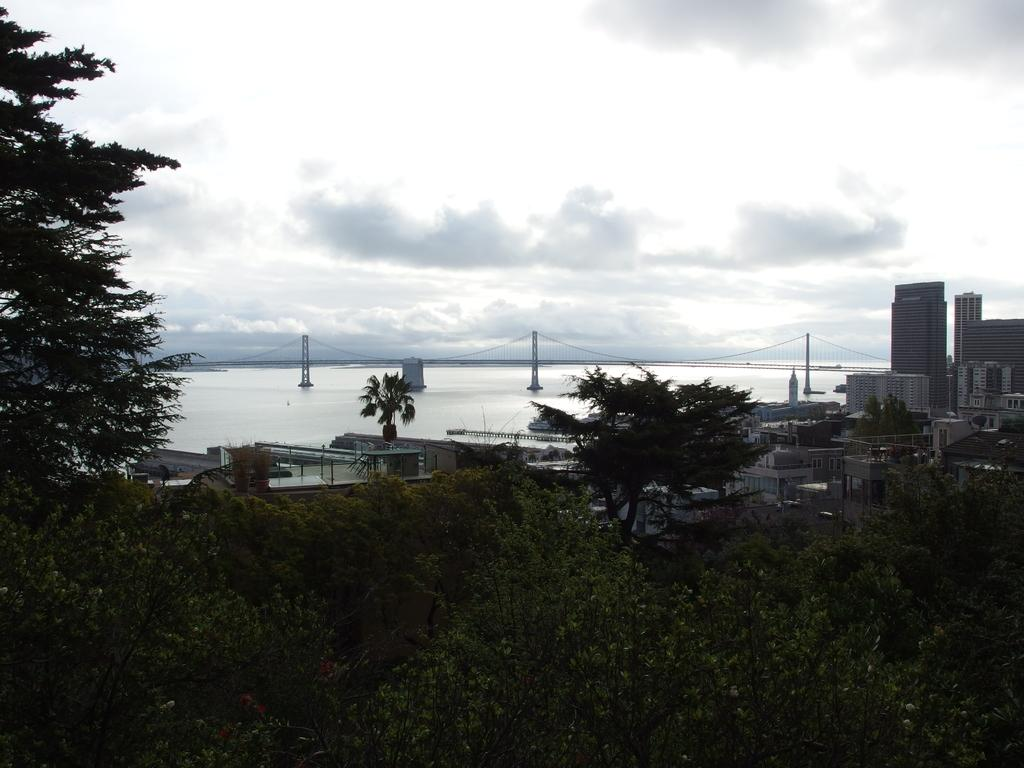What type of natural elements can be seen in the image? There are trees in the image. What type of man-made structures are visible in the image? There are houses and buildings in the image. What architectural feature can be seen in the background of the image? There is a bridge in the background of the image. What natural element is present in the background of the image? There is water in the background of the image. How would you describe the weather in the image? The sky is cloudy at the top of the image, suggesting a potentially overcast or cloudy day. Can you tell me how many pickles are hanging from the trees in the image? There are no pickles present in the image; it features trees, houses, buildings, a bridge, water, and a cloudy sky. What letters are written on the bridge in the image? There are no letters visible on the bridge in the image. 